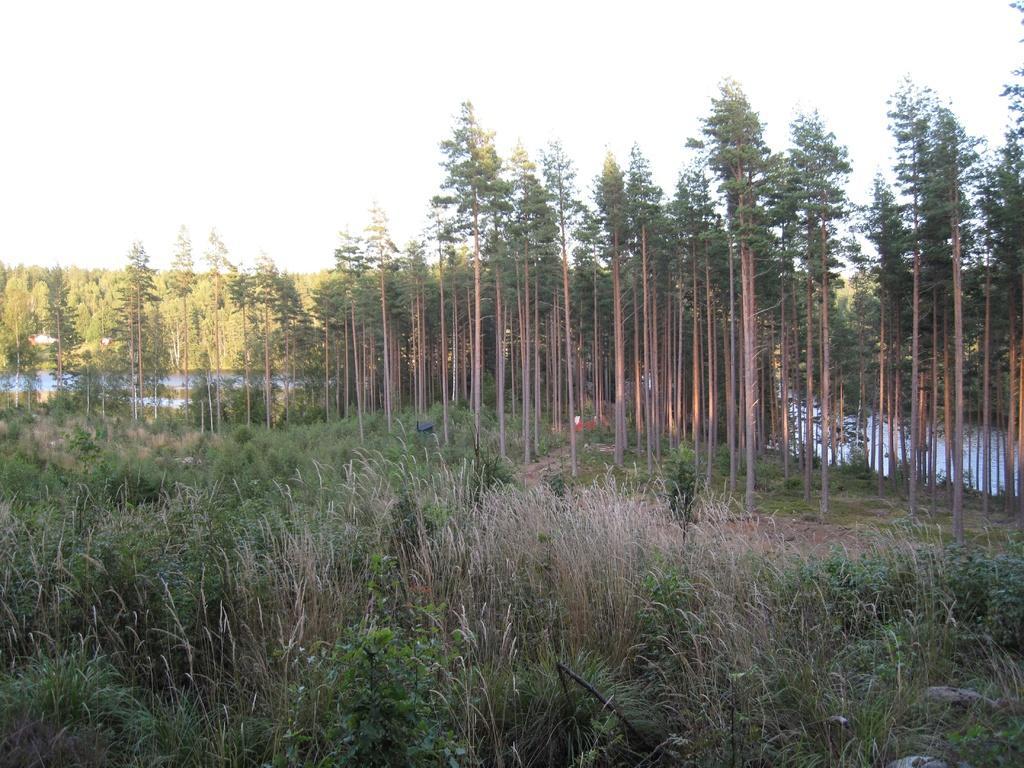How would you summarize this image in a sentence or two? In this image we can see a group of trees, plants, grass, water and the sky which looks cloudy. 